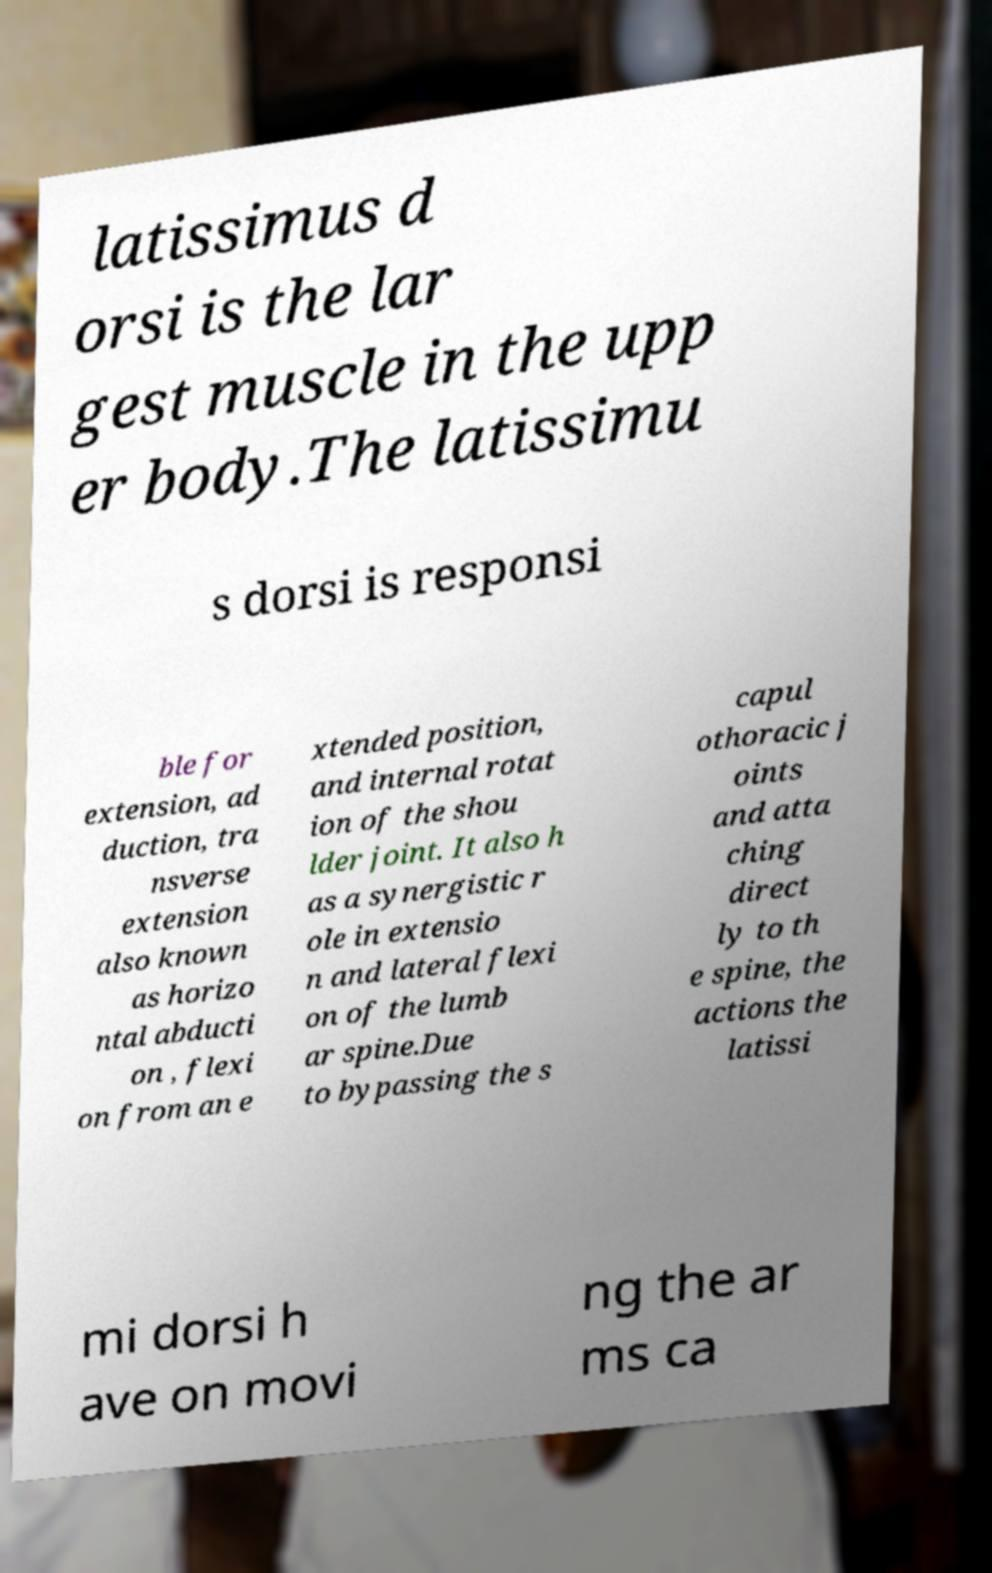Can you accurately transcribe the text from the provided image for me? latissimus d orsi is the lar gest muscle in the upp er body.The latissimu s dorsi is responsi ble for extension, ad duction, tra nsverse extension also known as horizo ntal abducti on , flexi on from an e xtended position, and internal rotat ion of the shou lder joint. It also h as a synergistic r ole in extensio n and lateral flexi on of the lumb ar spine.Due to bypassing the s capul othoracic j oints and atta ching direct ly to th e spine, the actions the latissi mi dorsi h ave on movi ng the ar ms ca 